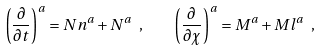<formula> <loc_0><loc_0><loc_500><loc_500>\left ( \frac { \partial } { \partial t } \right ) ^ { a } = N n ^ { a } + N ^ { a } \ , \quad \left ( \frac { \partial } { \partial \chi } \right ) ^ { a } = M ^ { a } + M l ^ { a } \ ,</formula> 